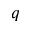<formula> <loc_0><loc_0><loc_500><loc_500>q</formula> 